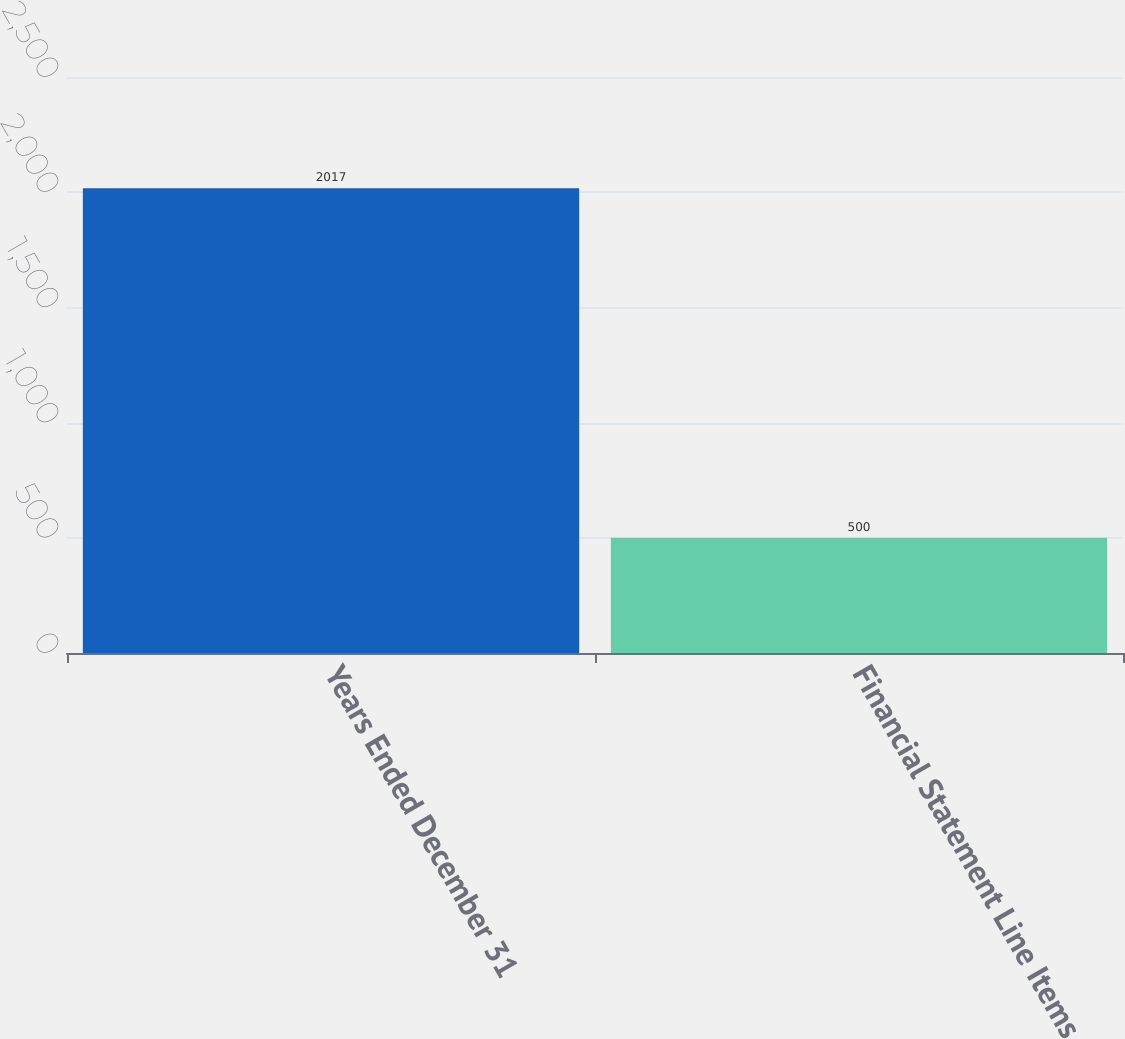<chart> <loc_0><loc_0><loc_500><loc_500><bar_chart><fcel>Years Ended December 31<fcel>Financial Statement Line Items<nl><fcel>2017<fcel>500<nl></chart> 